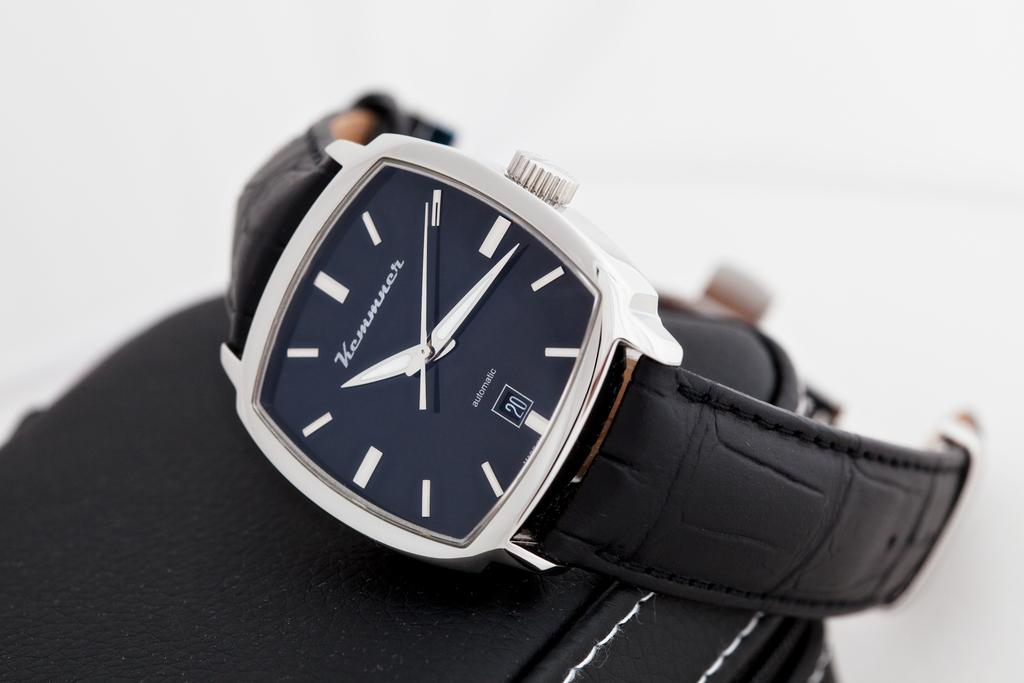<image>
Relay a brief, clear account of the picture shown. An automatic watch has tick marks for the hours and a date of the 20th. 